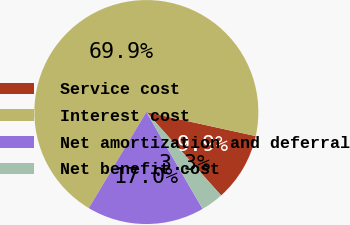Convert chart. <chart><loc_0><loc_0><loc_500><loc_500><pie_chart><fcel>Service cost<fcel>Interest cost<fcel>Net amortization and deferral<fcel>Net benefit cost<nl><fcel>9.92%<fcel>69.85%<fcel>16.96%<fcel>3.26%<nl></chart> 